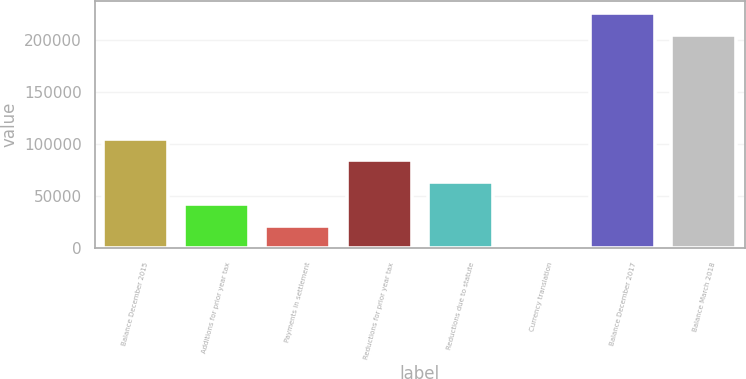Convert chart. <chart><loc_0><loc_0><loc_500><loc_500><bar_chart><fcel>Balance December 2015<fcel>Additions for prior year tax<fcel>Payments in settlement<fcel>Reductions for prior year tax<fcel>Reductions due to statute<fcel>Currency translation<fcel>Balance December 2017<fcel>Balance March 2018<nl><fcel>105072<fcel>42068.4<fcel>21067.2<fcel>84070.8<fcel>63069.6<fcel>66<fcel>225516<fcel>204515<nl></chart> 